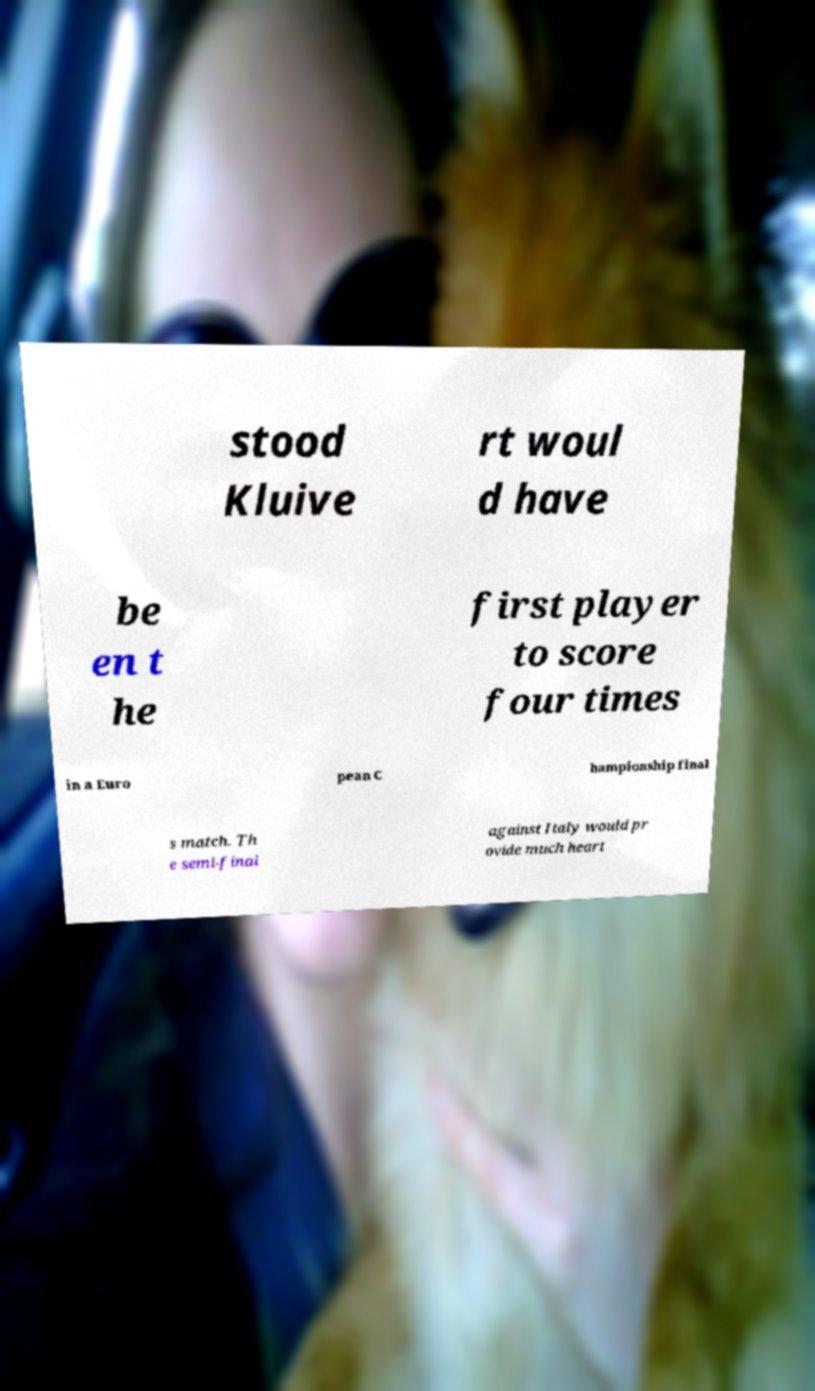I need the written content from this picture converted into text. Can you do that? stood Kluive rt woul d have be en t he first player to score four times in a Euro pean C hampionship final s match. Th e semi-final against Italy would pr ovide much heart 